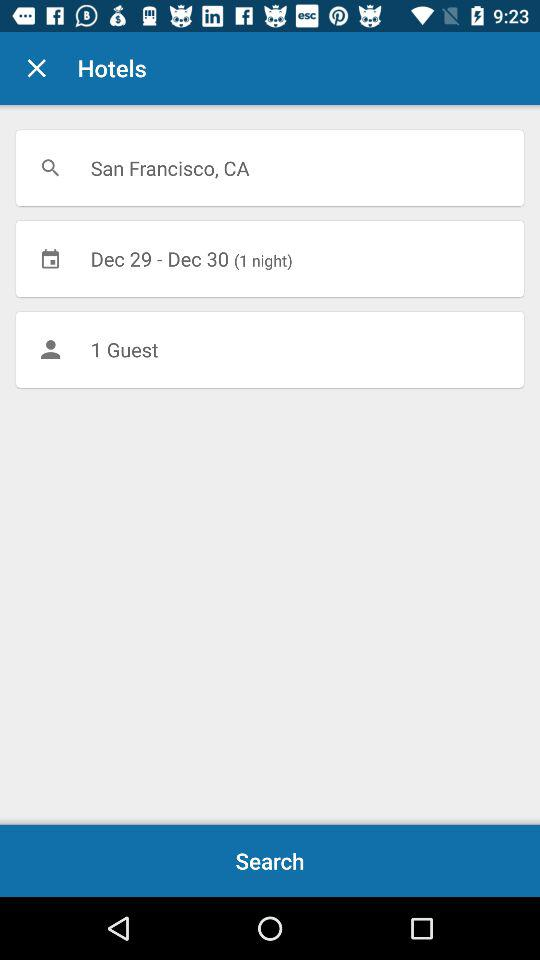What is the location in which hotels are searched? The location in which hotels are searched is San Francisco, CA. 